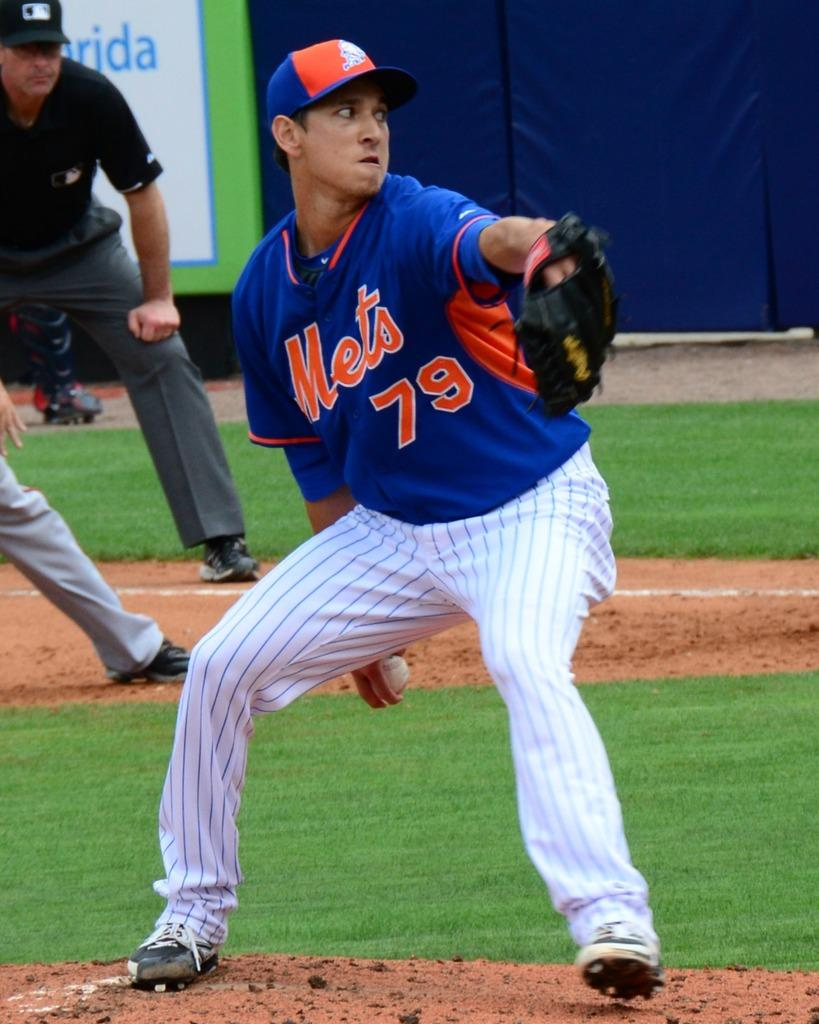<image>
Provide a brief description of the given image. a mets player number 79  ready to throw the baseball 